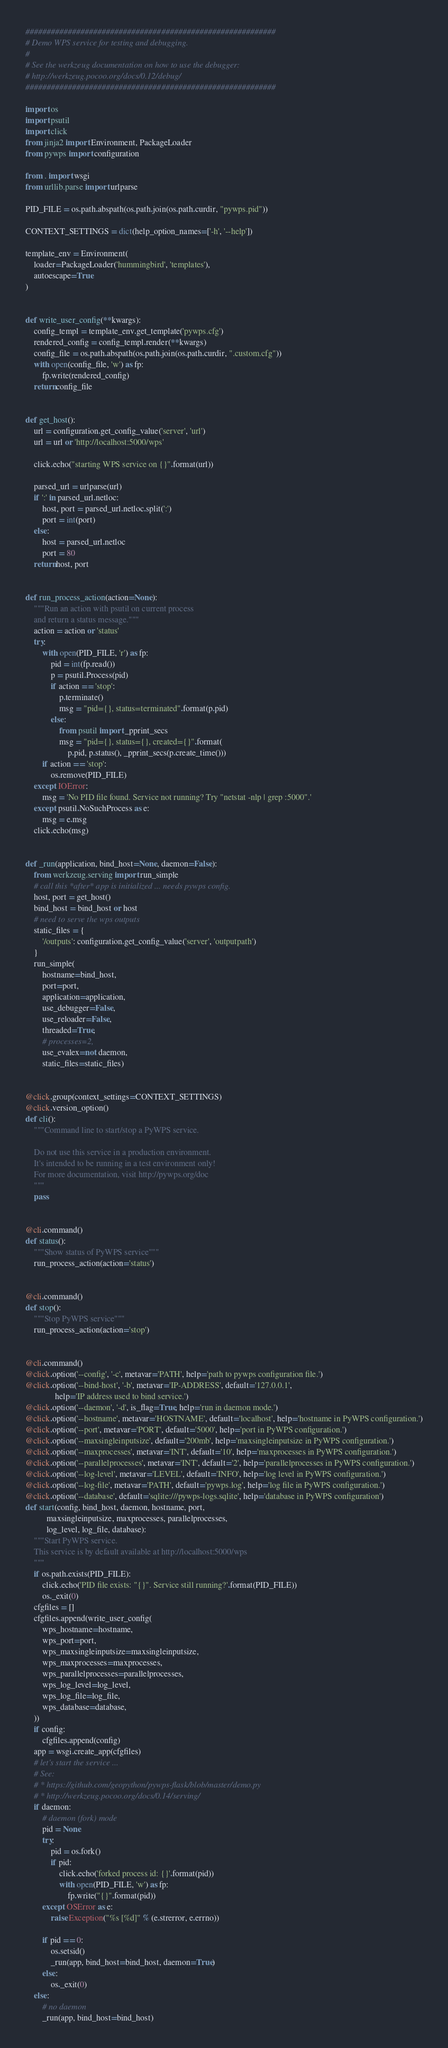<code> <loc_0><loc_0><loc_500><loc_500><_Python_>###########################################################
# Demo WPS service for testing and debugging.
#
# See the werkzeug documentation on how to use the debugger:
# http://werkzeug.pocoo.org/docs/0.12/debug/
###########################################################

import os
import psutil
import click
from jinja2 import Environment, PackageLoader
from pywps import configuration

from . import wsgi
from urllib.parse import urlparse

PID_FILE = os.path.abspath(os.path.join(os.path.curdir, "pywps.pid"))

CONTEXT_SETTINGS = dict(help_option_names=['-h', '--help'])

template_env = Environment(
    loader=PackageLoader('hummingbird', 'templates'),
    autoescape=True
)


def write_user_config(**kwargs):
    config_templ = template_env.get_template('pywps.cfg')
    rendered_config = config_templ.render(**kwargs)
    config_file = os.path.abspath(os.path.join(os.path.curdir, ".custom.cfg"))
    with open(config_file, 'w') as fp:
        fp.write(rendered_config)
    return config_file


def get_host():
    url = configuration.get_config_value('server', 'url')
    url = url or 'http://localhost:5000/wps'

    click.echo("starting WPS service on {}".format(url))

    parsed_url = urlparse(url)
    if ':' in parsed_url.netloc:
        host, port = parsed_url.netloc.split(':')
        port = int(port)
    else:
        host = parsed_url.netloc
        port = 80
    return host, port


def run_process_action(action=None):
    """Run an action with psutil on current process
    and return a status message."""
    action = action or 'status'
    try:
        with open(PID_FILE, 'r') as fp:
            pid = int(fp.read())
            p = psutil.Process(pid)
            if action == 'stop':
                p.terminate()
                msg = "pid={}, status=terminated".format(p.pid)
            else:
                from psutil import _pprint_secs
                msg = "pid={}, status={}, created={}".format(
                    p.pid, p.status(), _pprint_secs(p.create_time()))
        if action == 'stop':
            os.remove(PID_FILE)
    except IOError:
        msg = 'No PID file found. Service not running? Try "netstat -nlp | grep :5000".'
    except psutil.NoSuchProcess as e:
        msg = e.msg
    click.echo(msg)


def _run(application, bind_host=None, daemon=False):
    from werkzeug.serving import run_simple
    # call this *after* app is initialized ... needs pywps config.
    host, port = get_host()
    bind_host = bind_host or host
    # need to serve the wps outputs
    static_files = {
        '/outputs': configuration.get_config_value('server', 'outputpath')
    }
    run_simple(
        hostname=bind_host,
        port=port,
        application=application,
        use_debugger=False,
        use_reloader=False,
        threaded=True,
        # processes=2,
        use_evalex=not daemon,
        static_files=static_files)


@click.group(context_settings=CONTEXT_SETTINGS)
@click.version_option()
def cli():
    """Command line to start/stop a PyWPS service.

    Do not use this service in a production environment.
    It's intended to be running in a test environment only!
    For more documentation, visit http://pywps.org/doc
    """
    pass


@cli.command()
def status():
    """Show status of PyWPS service"""
    run_process_action(action='status')


@cli.command()
def stop():
    """Stop PyWPS service"""
    run_process_action(action='stop')


@cli.command()
@click.option('--config', '-c', metavar='PATH', help='path to pywps configuration file.')
@click.option('--bind-host', '-b', metavar='IP-ADDRESS', default='127.0.0.1',
              help='IP address used to bind service.')
@click.option('--daemon', '-d', is_flag=True, help='run in daemon mode.')
@click.option('--hostname', metavar='HOSTNAME', default='localhost', help='hostname in PyWPS configuration.')
@click.option('--port', metavar='PORT', default='5000', help='port in PyWPS configuration.')
@click.option('--maxsingleinputsize', default='200mb', help='maxsingleinputsize in PyWPS configuration.')
@click.option('--maxprocesses', metavar='INT', default='10', help='maxprocesses in PyWPS configuration.')
@click.option('--parallelprocesses', metavar='INT', default='2', help='parallelprocesses in PyWPS configuration.')
@click.option('--log-level', metavar='LEVEL', default='INFO', help='log level in PyWPS configuration.')
@click.option('--log-file', metavar='PATH', default='pywps.log', help='log file in PyWPS configuration.')
@click.option('--database', default='sqlite:///pywps-logs.sqlite', help='database in PyWPS configuration')
def start(config, bind_host, daemon, hostname, port,
          maxsingleinputsize, maxprocesses, parallelprocesses,
          log_level, log_file, database):
    """Start PyWPS service.
    This service is by default available at http://localhost:5000/wps
    """
    if os.path.exists(PID_FILE):
        click.echo('PID file exists: "{}". Service still running?'.format(PID_FILE))
        os._exit(0)
    cfgfiles = []
    cfgfiles.append(write_user_config(
        wps_hostname=hostname,
        wps_port=port,
        wps_maxsingleinputsize=maxsingleinputsize,
        wps_maxprocesses=maxprocesses,
        wps_parallelprocesses=parallelprocesses,
        wps_log_level=log_level,
        wps_log_file=log_file,
        wps_database=database,
    ))
    if config:
        cfgfiles.append(config)
    app = wsgi.create_app(cfgfiles)
    # let's start the service ...
    # See:
    # * https://github.com/geopython/pywps-flask/blob/master/demo.py
    # * http://werkzeug.pocoo.org/docs/0.14/serving/
    if daemon:
        # daemon (fork) mode
        pid = None
        try:
            pid = os.fork()
            if pid:
                click.echo('forked process id: {}'.format(pid))
                with open(PID_FILE, 'w') as fp:
                    fp.write("{}".format(pid))
        except OSError as e:
            raise Exception("%s [%d]" % (e.strerror, e.errno))

        if pid == 0:
            os.setsid()
            _run(app, bind_host=bind_host, daemon=True)
        else:
            os._exit(0)
    else:
        # no daemon
        _run(app, bind_host=bind_host)
</code> 